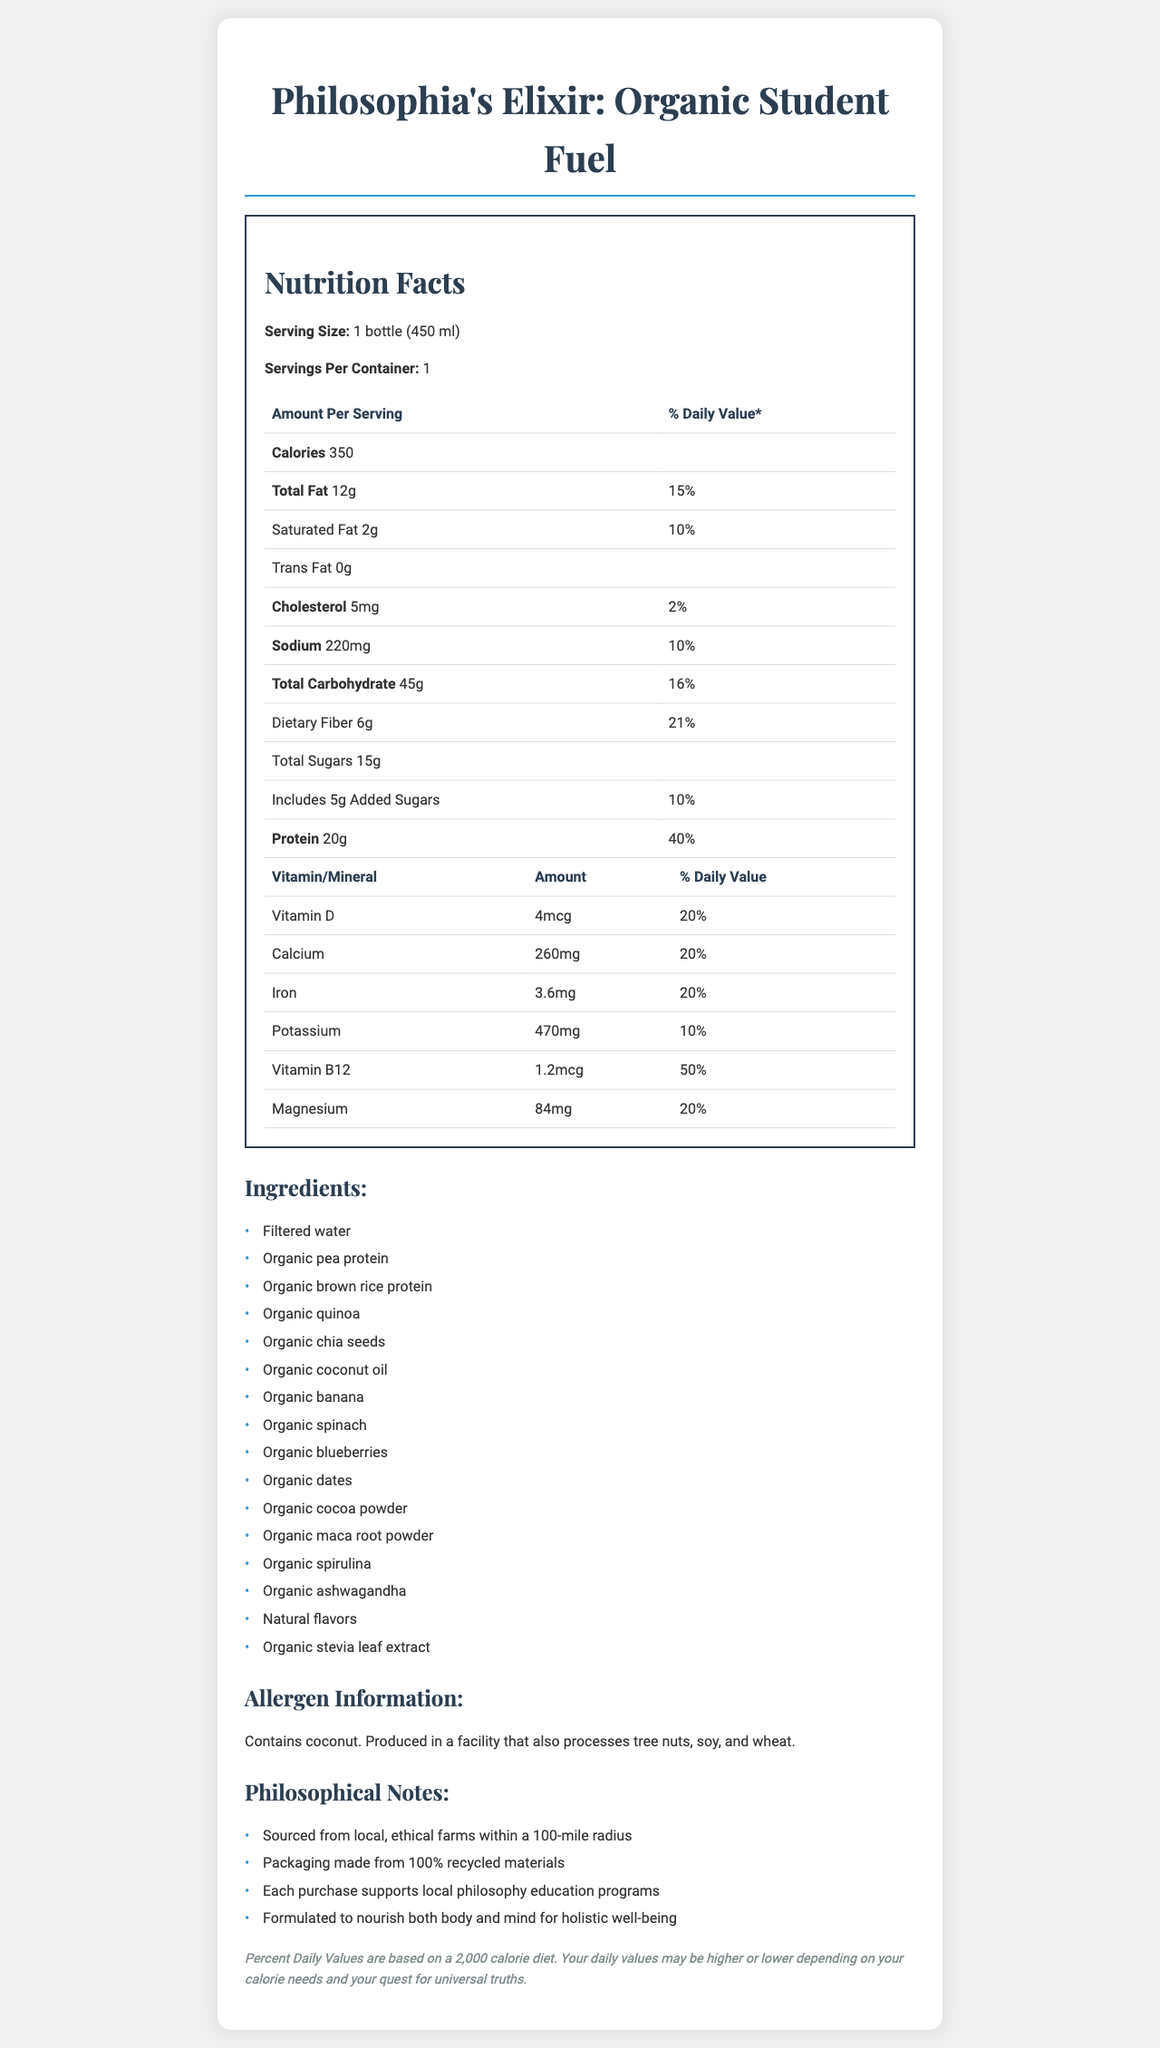what is the serving size? The serving size is specified in the document as "1 bottle (450 ml)".
Answer: 1 bottle (450 ml) what is the calorie content per serving? The document states that the calorie content per serving is 350 calories.
Answer: 350 calories how many grams of protein are there per serving? The document specifies that there are 20g of protein per serving.
Answer: 20g what is the percentage daily value of Vitamin D per serving? The document lists the daily value of Vitamin D per serving as 20%.
Answer: 20% how much dietary fiber does one serving contain? The document specifies that one serving contains 6g of dietary fiber.
Answer: 6g does the product contain any allergens? The document states that the product contains coconut and is produced in a facility that also processes tree nuts, soy, and wheat.
Answer: Yes how many grams of added sugars are there in one serving? The document specifies that one serving includes 5g of added sugars.
Answer: 5g what is the daily value percentage for calcium per serving? A. 10% B. 20% C. 30% D. 50% The document lists the daily value percentage for calcium per serving as 20%.
Answer: B which ingredient is not found in the product? A. Organic pea protein B. Organic spinach C. Organic honey The document lists all ingredients and does not include organic honey.
Answer: C is the product formulated to support local philosophy education programs? The document mentions that each purchase supports local philosophy education programs.
Answer: Yes briefly summarize the main idea of the document. The document contains comprehensive nutrition information and additional notes linking the product to ethical practices and educational support.
Answer: The document provides detailed nutrition facts for "Philosophia's Elixir: Organic Student Fuel", an organic, locally-sourced meal replacement shake. It includes information on serving size, calorie content, macronutrients, vitamins, minerals, ingredients, allergen information, and philosophical notes emphasizing ethical sourcing, recycled packaging, and educational support. what is the total fat content, and how does it break down into saturated and trans fat? The document states that the total fat content is 12g, which includes 2g of saturated fat and no trans fat.
Answer: 12g total fat, 2g saturated fat, 0g trans fat what percentage of the daily value is provided for iron per serving? The document specifies that the iron daily value per serving is 20%.
Answer: 20% how many servings are there per container? The document states that there is 1 serving per container.
Answer: 1 serving how much sodium does one serving contain? The document specifies that one serving contains 220mg of sodium.
Answer: 220mg what is the philosophical essence reflected in the product according to the document? The document mentions the product's ethical sourcing, environmentally-friendly packaging, support for education, and holistic well-being goals.
Answer: The product is sourced from local farms, uses recycled materials, supports education, and aims for holistic well-being. what is the percentage daily value of Vitamin B12 per serving? The document lists the daily value for Vitamin B12 as 50%.
Answer: 50% which of the following is produced in the same facility as this product? A. Peanuts B. Tree nuts C. Dairy D. Eggs The document states that the product is produced in a facility that also processes tree nuts, soy, and wheat.
Answer: B does the product contain any form of sweetener? The document indicates that the product contains "organic stevia leaf extract" as a sweetener.
Answer: Yes can the total carbohydrates in this product be determined from the document? The document specifies the total carbohydrate amount as 45g per serving.
Answer: Yes 